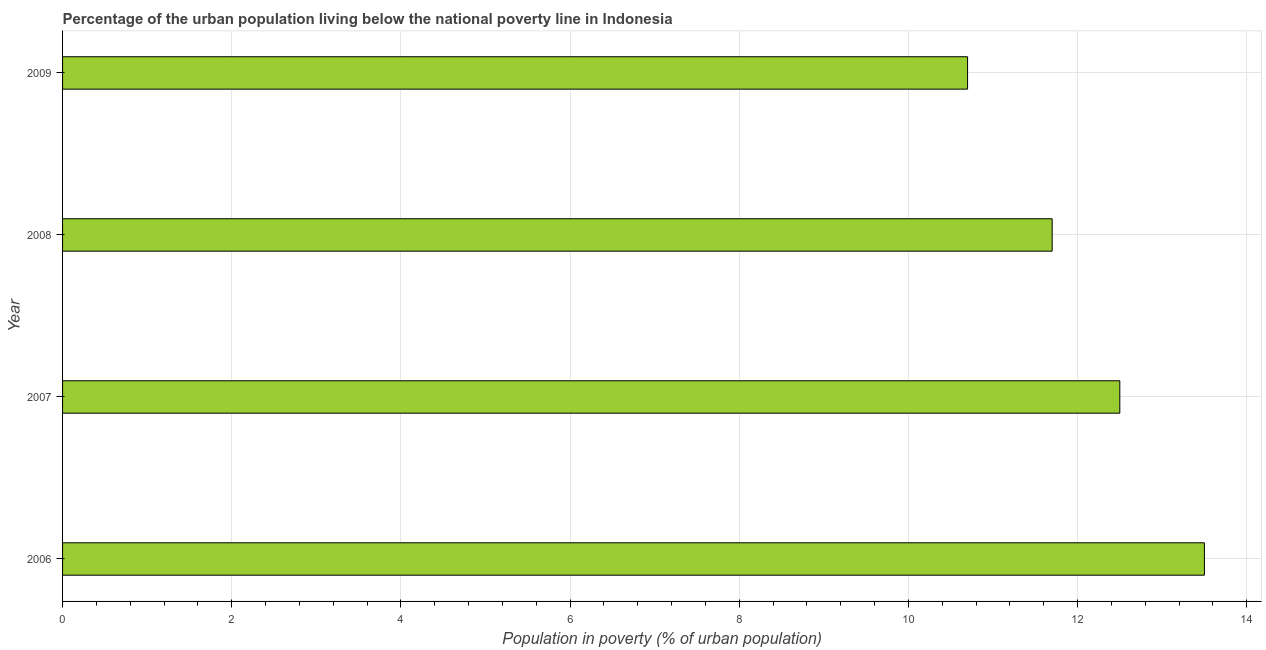Does the graph contain any zero values?
Your answer should be very brief. No. Does the graph contain grids?
Give a very brief answer. Yes. What is the title of the graph?
Keep it short and to the point. Percentage of the urban population living below the national poverty line in Indonesia. What is the label or title of the X-axis?
Provide a short and direct response. Population in poverty (% of urban population). In which year was the percentage of urban population living below poverty line minimum?
Ensure brevity in your answer.  2009. What is the sum of the percentage of urban population living below poverty line?
Your answer should be compact. 48.4. What is the median percentage of urban population living below poverty line?
Provide a succinct answer. 12.1. Do a majority of the years between 2009 and 2007 (inclusive) have percentage of urban population living below poverty line greater than 2 %?
Your answer should be very brief. Yes. What is the ratio of the percentage of urban population living below poverty line in 2008 to that in 2009?
Ensure brevity in your answer.  1.09. What is the difference between the highest and the lowest percentage of urban population living below poverty line?
Provide a succinct answer. 2.8. In how many years, is the percentage of urban population living below poverty line greater than the average percentage of urban population living below poverty line taken over all years?
Make the answer very short. 2. How many bars are there?
Your response must be concise. 4. How many years are there in the graph?
Keep it short and to the point. 4. What is the difference between two consecutive major ticks on the X-axis?
Give a very brief answer. 2. What is the Population in poverty (% of urban population) of 2008?
Make the answer very short. 11.7. What is the difference between the Population in poverty (% of urban population) in 2006 and 2008?
Your answer should be very brief. 1.8. What is the difference between the Population in poverty (% of urban population) in 2006 and 2009?
Your response must be concise. 2.8. What is the difference between the Population in poverty (% of urban population) in 2007 and 2008?
Your response must be concise. 0.8. What is the difference between the Population in poverty (% of urban population) in 2007 and 2009?
Your answer should be compact. 1.8. What is the difference between the Population in poverty (% of urban population) in 2008 and 2009?
Give a very brief answer. 1. What is the ratio of the Population in poverty (% of urban population) in 2006 to that in 2008?
Make the answer very short. 1.15. What is the ratio of the Population in poverty (% of urban population) in 2006 to that in 2009?
Offer a terse response. 1.26. What is the ratio of the Population in poverty (% of urban population) in 2007 to that in 2008?
Provide a succinct answer. 1.07. What is the ratio of the Population in poverty (% of urban population) in 2007 to that in 2009?
Your response must be concise. 1.17. What is the ratio of the Population in poverty (% of urban population) in 2008 to that in 2009?
Provide a succinct answer. 1.09. 